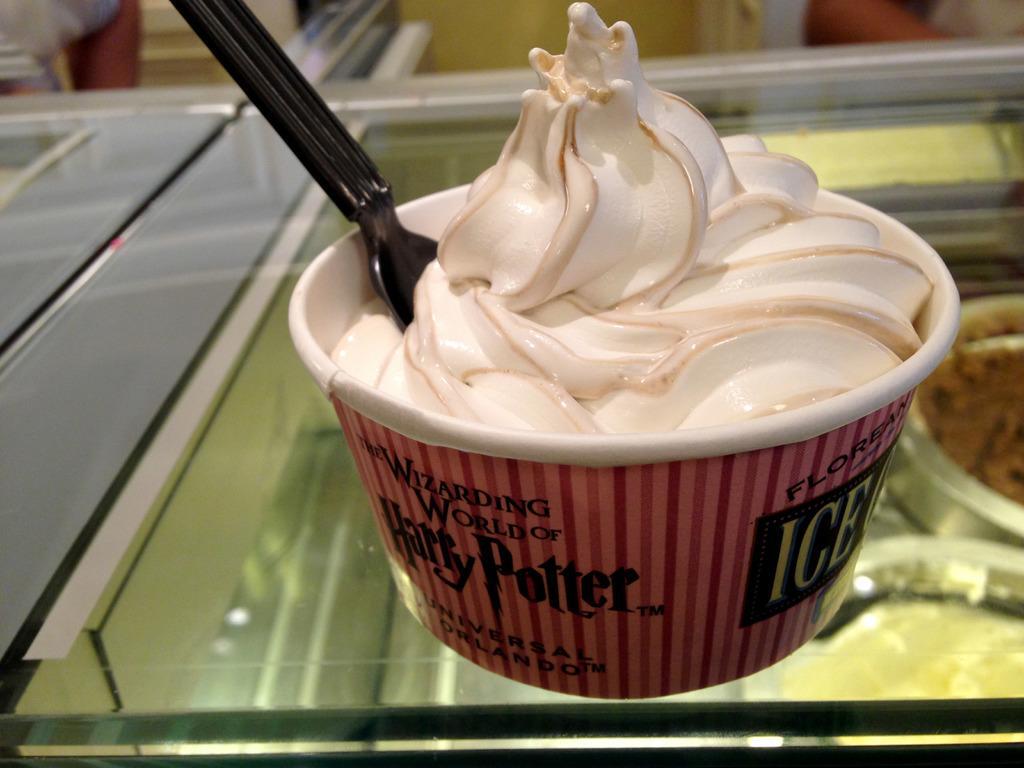In one or two sentences, can you explain what this image depicts? In this image there is a glass, on that glass there is a cup, in that cup there is ice cream and a spoon. 